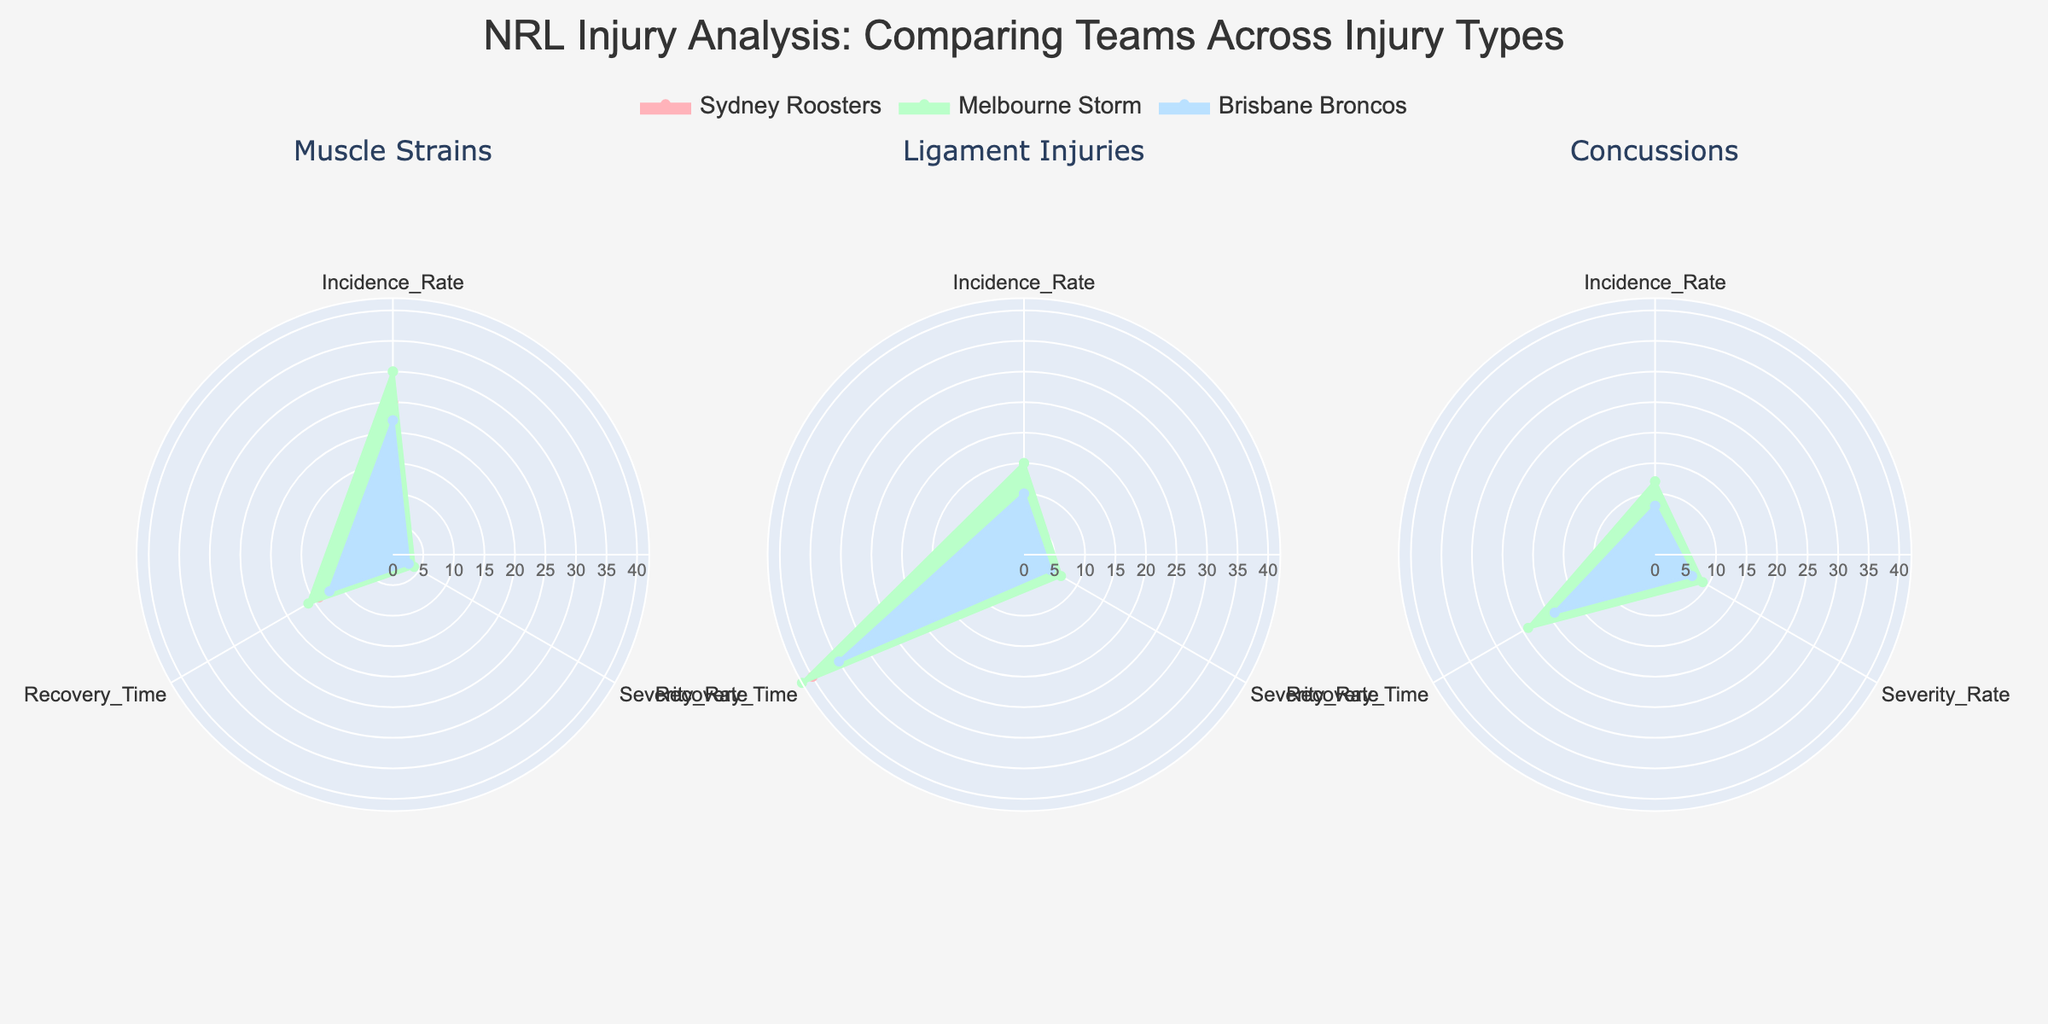What's the title of the radar chart? The title of the radar chart is always prominently displayed at the top due to its larger font size and central alignment.
Answer: NRL Injury Analysis: Comparing Teams Across Injury Types Which injury type has the highest Recovery Time for the Sydney Roosters? By examining the radial axes under the "Sydney Roosters" section, we can observe the 'Recovery Time' intersection for each injury type.
Answer: Ligament Injuries How does the Severity Rate of concussions compare between Melbourne Storm and Brisbane Broncos? By focusing on the 'Severity Rate' radial axis for Concusions, we see that Melbourne Storm (9) has a higher Severity Rate than Brisbane Broncos (7).
Answer: Melbourne Storm has a higher Severity Rate than Brisbane Broncos What is the average Incidence Rate for Muscle Strains across all three teams? Adding the Incidence Rates for all three teams (25 + 30 + 22) gives us 77, and dividing by 3 gives us the average.
Answer: 25.67 Which team has the lowest Incidence Rate for Ligament Injuries? By comparing the 'Incidence Rate' radial axes for Ligament Injuries, we see Brisbane Broncos have the lowest value at 10.
Answer: Brisbane Broncos Considering all three injury types, which team has the highest Severity Rate? By examining all Severity Rate values for each team in the radar plots, Melbourne Storm has the highest severity rate for Ligament Injuries (7) and Concussions (9).
Answer: Melbourne Storm Compare the Recovery Time for Concussions across all teams. The radar chart displays Brisbane Broncos with a Recovery Time of 19, Sydney Roosters at 21, and Melbourne Storm at 24 for Concussions.
Answer: Melbourne Storm > Sydney Roosters > Brisbane Broncos 